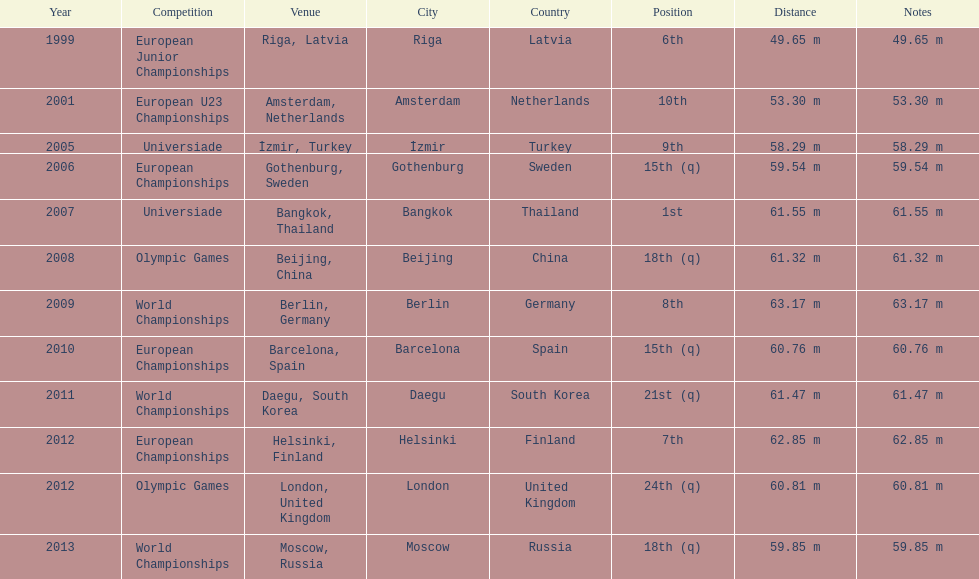What was mayer's best result: i.e his longest throw? 63.17 m. 